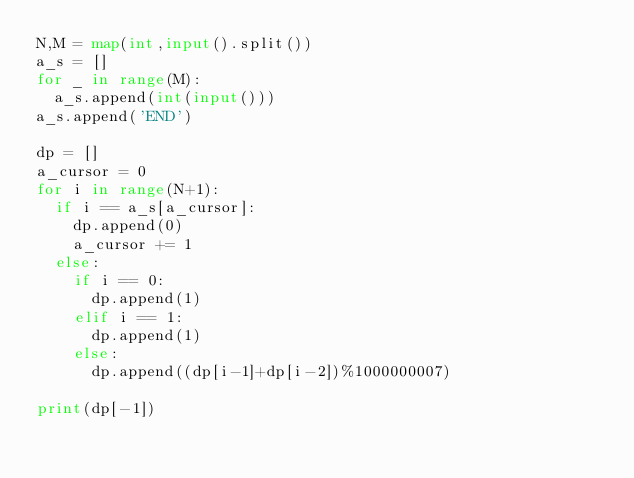<code> <loc_0><loc_0><loc_500><loc_500><_Python_>N,M = map(int,input().split())
a_s = []
for _ in range(M):
  a_s.append(int(input()))
a_s.append('END')
  
dp = []
a_cursor = 0
for i in range(N+1):
  if i == a_s[a_cursor]:
    dp.append(0)
    a_cursor += 1
  else:
    if i == 0:
      dp.append(1)
    elif i == 1:
      dp.append(1)
    else:
      dp.append((dp[i-1]+dp[i-2])%1000000007)
      
print(dp[-1])</code> 